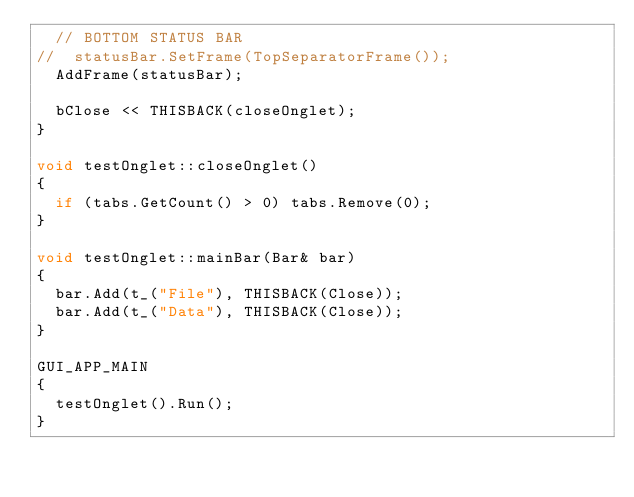<code> <loc_0><loc_0><loc_500><loc_500><_C++_>	// BOTTOM STATUS BAR
//	statusBar.SetFrame(TopSeparatorFrame());
	AddFrame(statusBar);
	
	bClose << THISBACK(closeOnglet);
}

void testOnglet::closeOnglet()
{
	if (tabs.GetCount() > 0) tabs.Remove(0);
}

void testOnglet::mainBar(Bar& bar)
{
	bar.Add(t_("File"), THISBACK(Close));
	bar.Add(t_("Data"), THISBACK(Close));
}

GUI_APP_MAIN
{
	testOnglet().Run();
}

</code> 